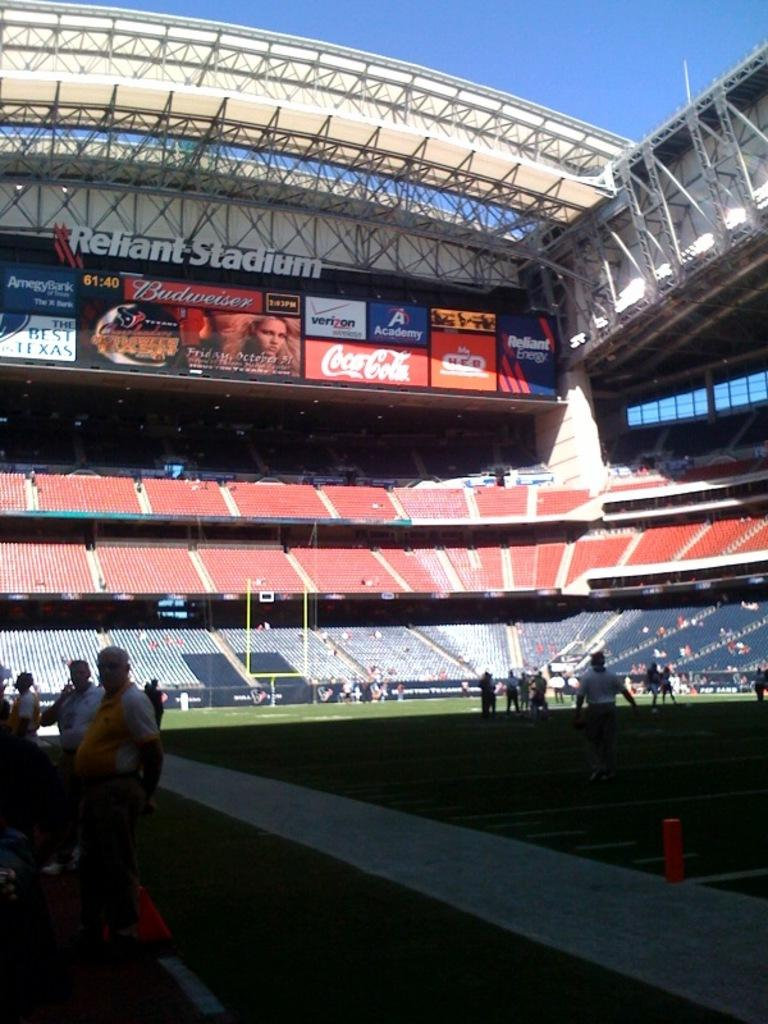<image>
Render a clear and concise summary of the photo. A sign that says Reliant Stadium is above the stands at a football stadium. 